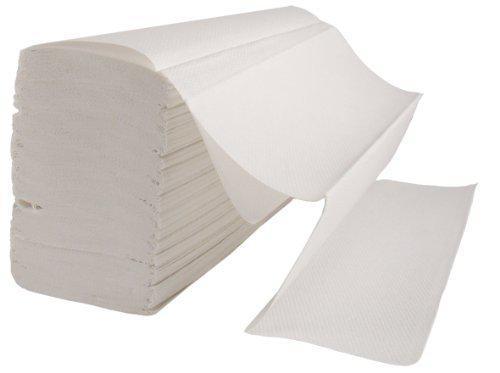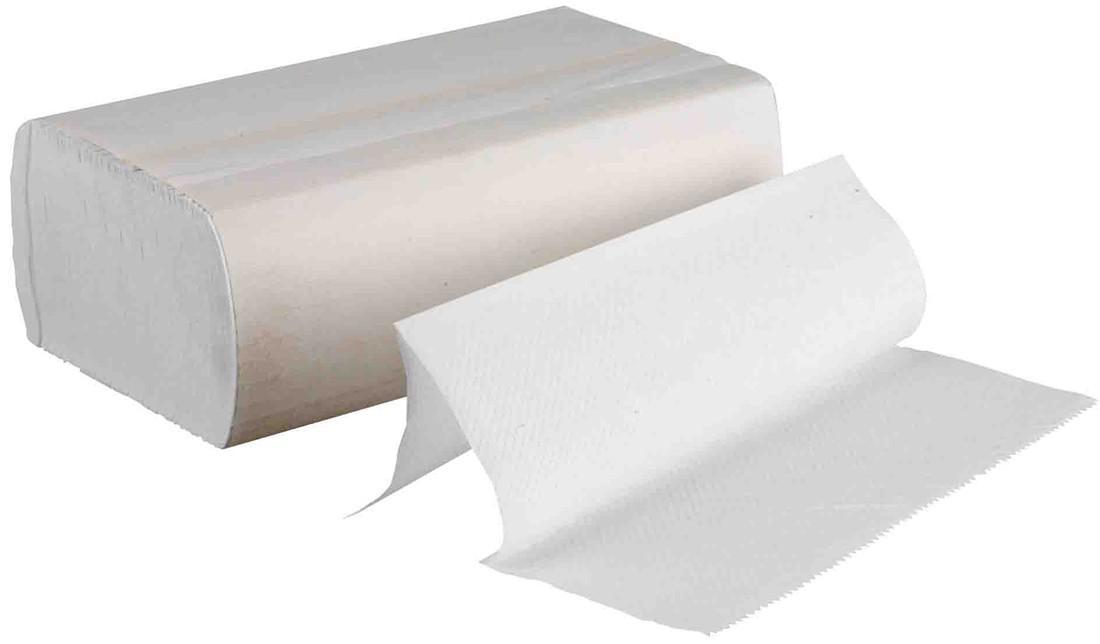The first image is the image on the left, the second image is the image on the right. Examine the images to the left and right. Is the description "Each image shows a white paper roll hung on a dispenser." accurate? Answer yes or no. No. The first image is the image on the left, the second image is the image on the right. Considering the images on both sides, is "Each roll of toilet paper is hanging on a dispenser." valid? Answer yes or no. No. 